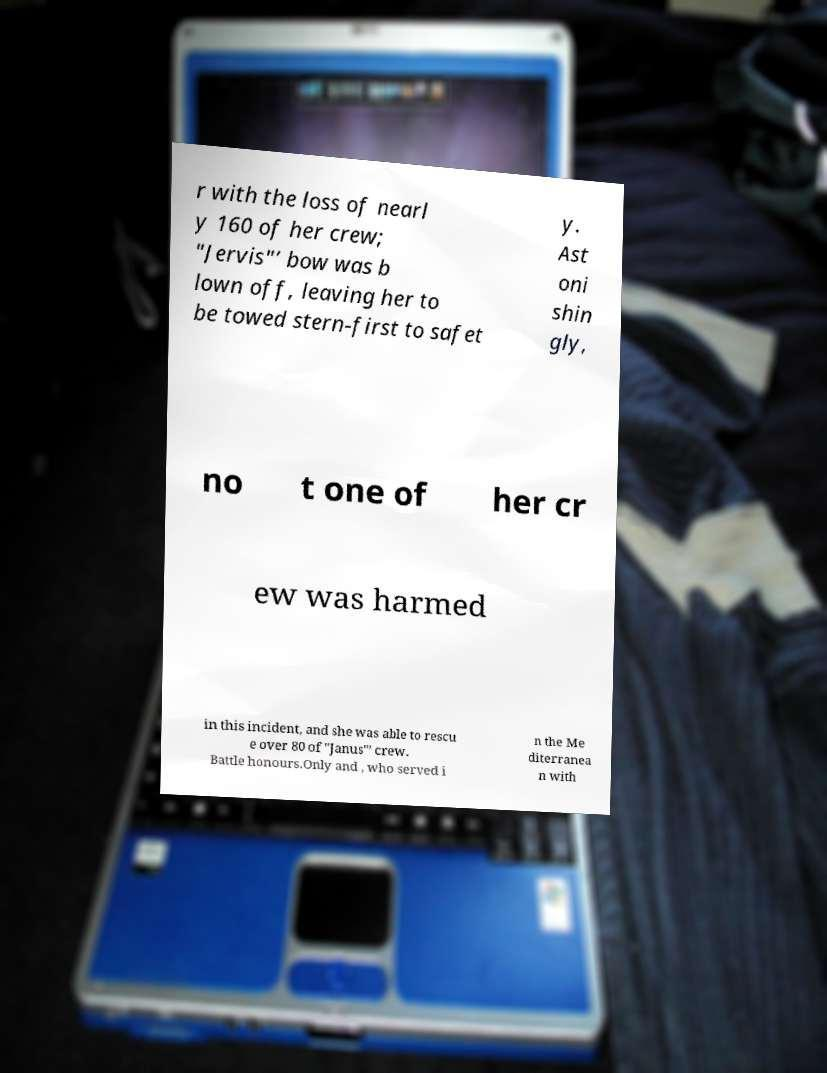Could you extract and type out the text from this image? r with the loss of nearl y 160 of her crew; "Jervis"’ bow was b lown off, leaving her to be towed stern-first to safet y. Ast oni shin gly, no t one of her cr ew was harmed in this incident, and she was able to rescu e over 80 of "Janus"’ crew. Battle honours.Only and , who served i n the Me diterranea n with 